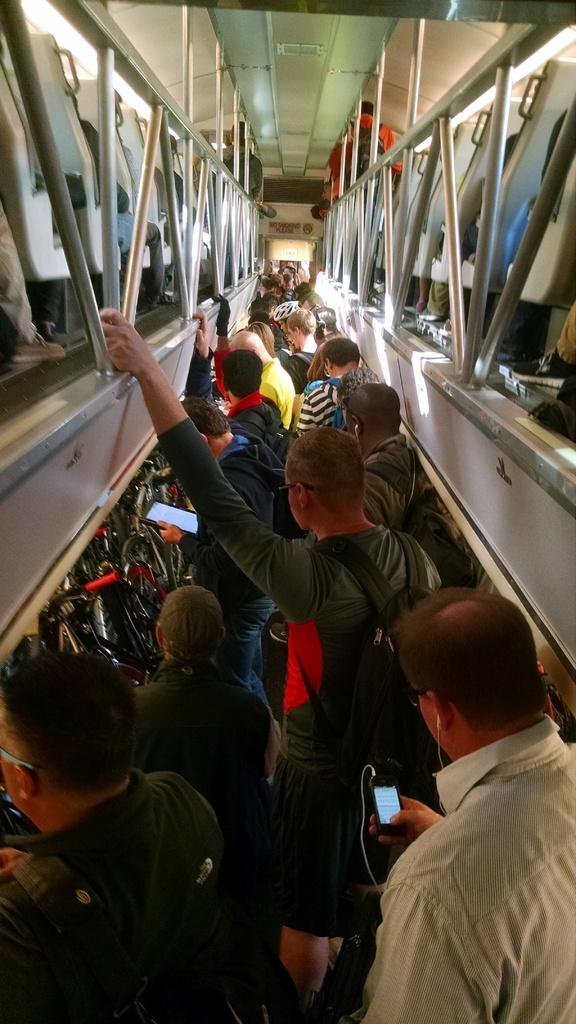What is the setting of the image? The image shows the inside of a vehicle. What are the people in the image doing? There are people walking in a path within the vehicle. What can be seen above the walking people? There are seats visible above the walking people. What are the people on the seats doing? There are people sitting on the seats. What type of structure is present in the image? Grilles are present in the image. What type of vest is being worn by the people in the image? There is no mention of vests in the image, so it cannot be determined what type of vest, if any, is being worn. 